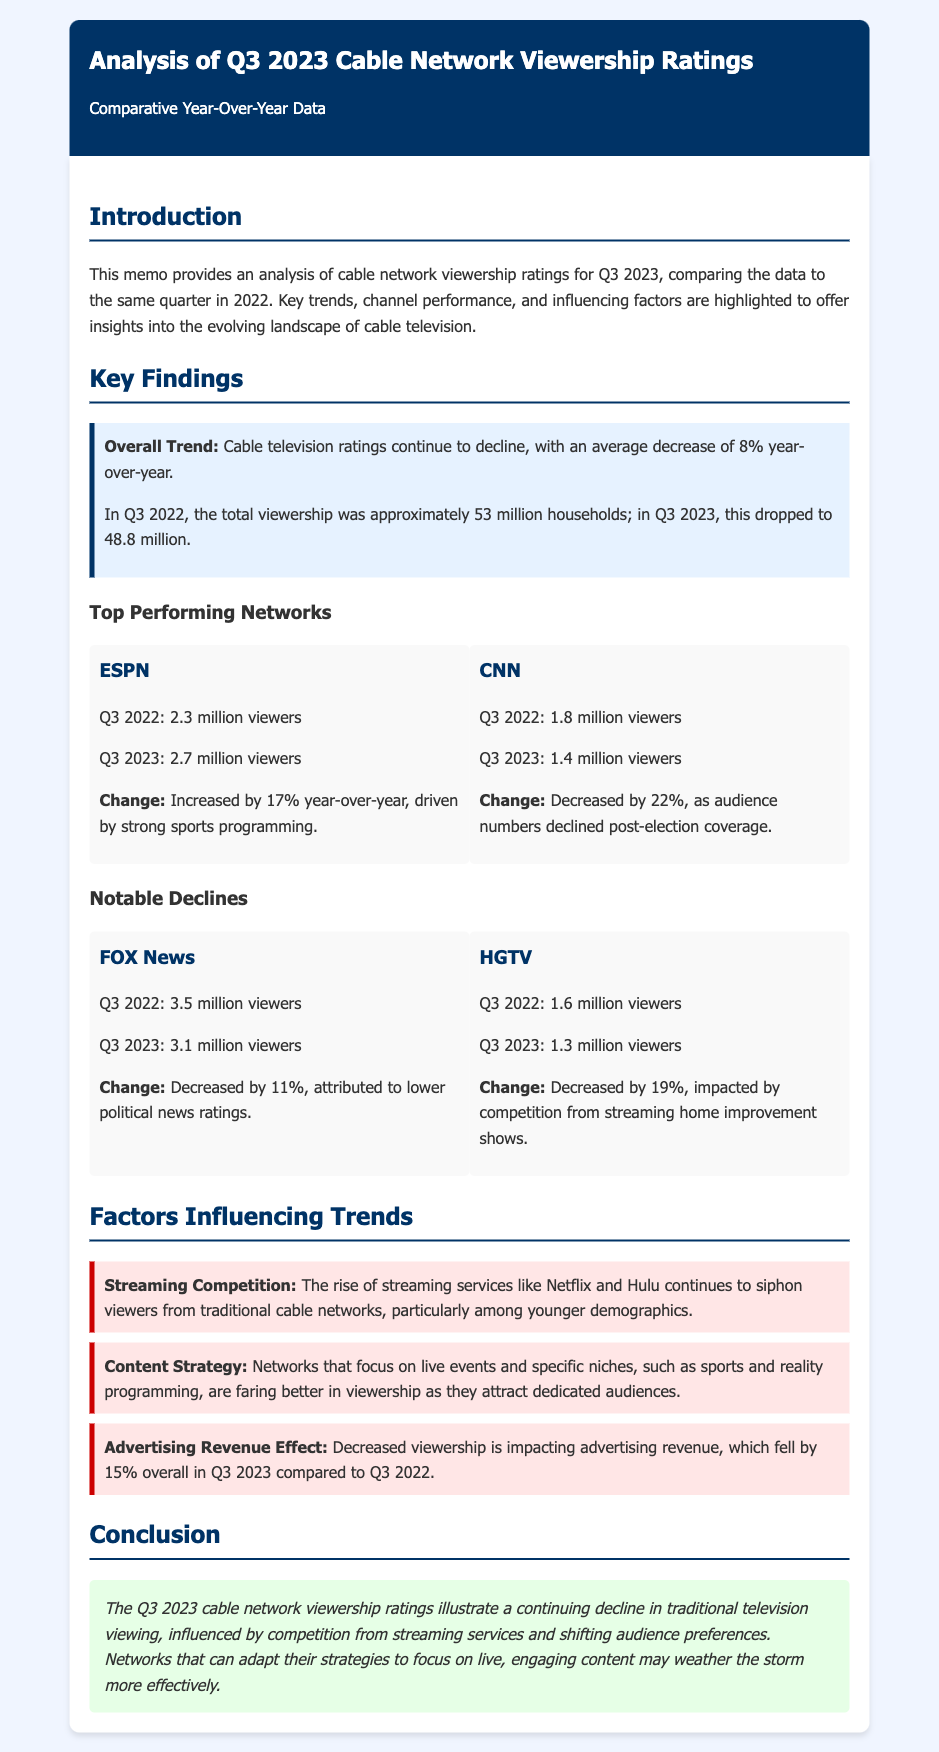What was the overall trend in cable television ratings? The memo indicates a decline in cable television ratings, specifically an average decrease of 8% year-over-year.
Answer: 8% decrease How many viewers did ESPN have in Q3 2023? According to the document, ESPN had 2.7 million viewers in Q3 2023.
Answer: 2.7 million viewers What was the viewership change for CNN from Q3 2022 to Q3 2023? The document states that CNN's viewership decreased by 22% year-over-year from Q3 2022 to Q3 2023.
Answer: 22% Which network experienced the highest number of viewers in Q3 2022? FOX News had the highest number of viewers in Q3 2022, with 3.5 million viewers.
Answer: 3.5 million viewers What factor is identified as influencing the decline in cable network viewership? The rise of streaming services like Netflix and Hulu is mentioned as a factor influencing the decline in viewership.
Answer: Streaming competition What was the advertising revenue effect mentioned in the memo? The document notes that advertising revenue fell by 15% overall in Q3 2023 compared to Q3 2022.
Answer: 15% decrease What is the tone of the conclusion in the memo? The conclusion presents a cautious outlook on the future of traditional television viewing, suggesting that networks must adapt.
Answer: Cautious outlook Which network was reported to have a viewership decline due to competition from streaming shows? The document highlights HGTV as a network facing viewership decline due to competition from streaming home improvement shows.
Answer: HGTV 